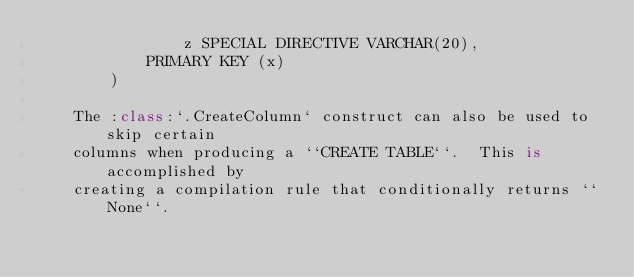<code> <loc_0><loc_0><loc_500><loc_500><_Python_>                z SPECIAL DIRECTIVE VARCHAR(20),
            PRIMARY KEY (x)
        )

    The :class:`.CreateColumn` construct can also be used to skip certain
    columns when producing a ``CREATE TABLE``.  This is accomplished by
    creating a compilation rule that conditionally returns ``None``.</code> 